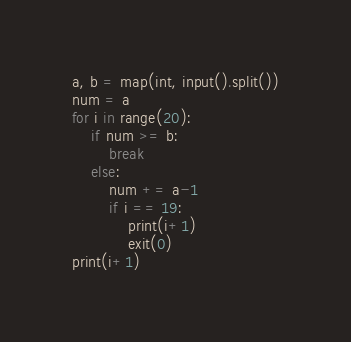<code> <loc_0><loc_0><loc_500><loc_500><_Python_>a, b = map(int, input().split())
num = a
for i in range(20):
    if num >= b:
        break
    else:
        num += a-1
        if i == 19:
            print(i+1)
            exit(0)
print(i+1)</code> 